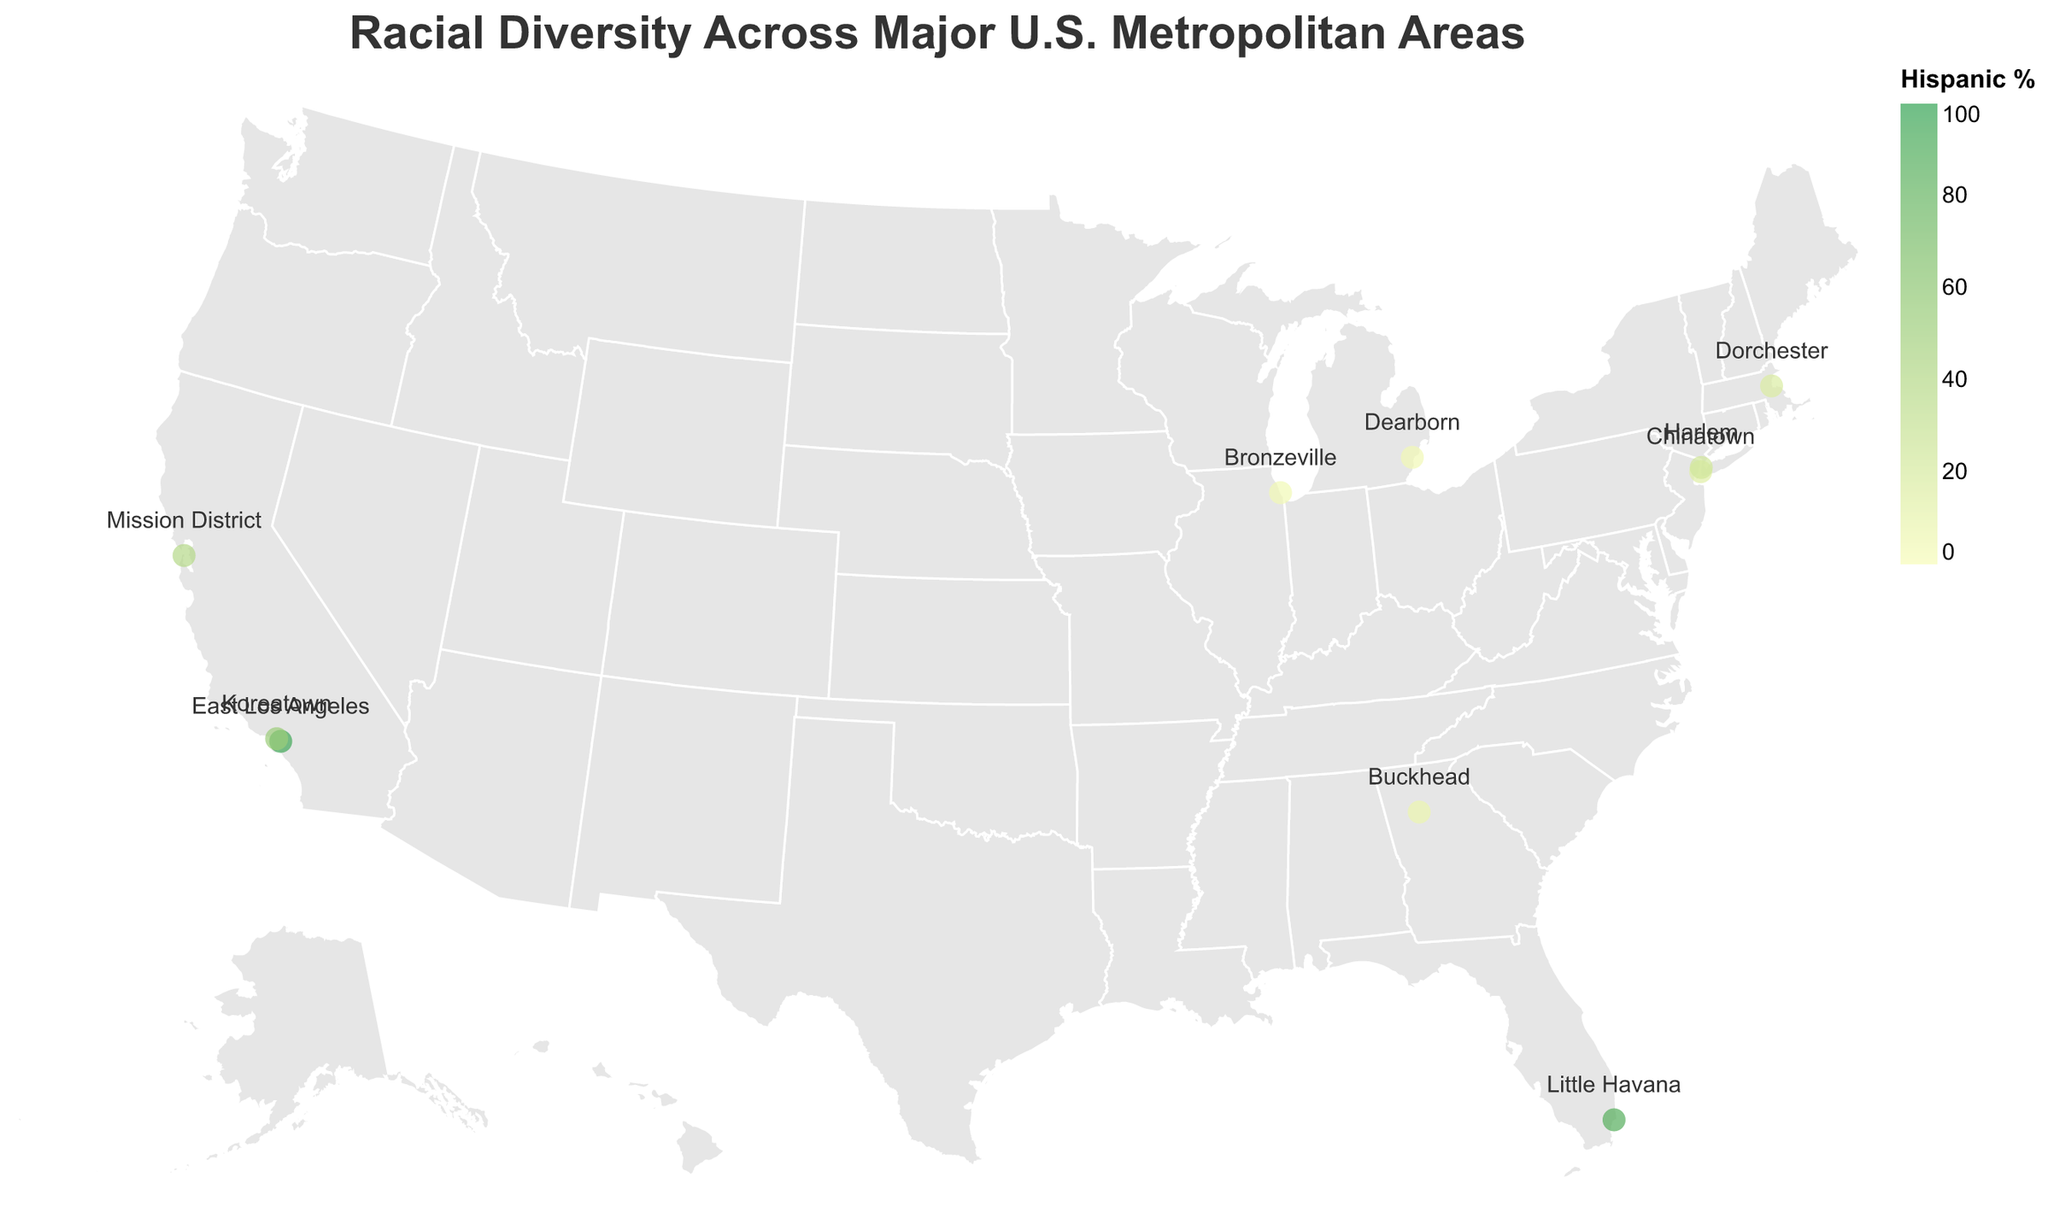What's the title of the figure? The title of the figure is usually displayed at the top of the visualization and describes the main topic of the plot.
Answer: Racial Diversity Across Major U.S. Metropolitan Areas What city has the neighborhood with the highest Hispanic percentage? From the tooltip or the color intensity of the circles representing Hispanic percentages, we can see that East Los Angeles, within Los Angeles, CA, has the highest Hispanic percentage at 95.1%.
Answer: Los Angeles Which neighborhood has the highest percentage of Asian residents? Check the figure for the neighborhood circle with the highest value for the Asian percentage in the tooltip. Chinatown, New York City, has the highest percentage of Asian residents at 63.9%.
Answer: Chinatown, New York City Compare the White percentage between Dearborn and Little Havana. Which one is higher? From the tooltip, we can see that Dearborn has 89.1% White residents while Little Havana has 7.2%. Therefore, Dearborn has a higher percentage of White residents.
Answer: Dearborn Which neighborhood has the most balanced racial diversity, considering the available percentages? To determine the most balanced racial diversity, look for the neighborhood where the different racial groups' percentages are relatively close to each other. Dorchester, Boston appears to have a relatively balanced mix with White 22.7%, Black 45.3%, Hispanic 17.6%, and Asian 9.8%.
Answer: Dorchester, Boston What's the percentage of Black residents in Harlem? Refer to the tooltip of Harlem in New York City to get the value of the Black percentage, which is 54.3%.
Answer: 54.3% How does the Hispanic percentage in the Mission District compare to that in Koreatown? The figure shows that the Mission District has a Hispanic percentage of 39.6%, while Koreatown has 53.5%. Therefore, the Hispanic percentage is higher in Koreatown.
Answer: Koreatown What is the primary ethnicity in Little Havana, Miami? According to the tooltip in the figure for Little Havana, the highest percentage is for Hispanic residents at 87.3%. This indicates the primary ethnicity.
Answer: Hispanic What is the general geographical distribution of neighborhoods with high Black populations? Look at the figure for areas with a dark color indicative of higher Black percentages. Neighborhoods like Bronzeville in Chicago and Harlem in New York City, which are spread across the Midwest and East Coast, stand out.
Answer: Midwest and East Coast Identify the neighborhood with the lowest percentage of Black residents. By checking the figure tooltips, East Los Angeles has the lowest percentage of Black residents at 0.8%.
Answer: East Los Angeles 